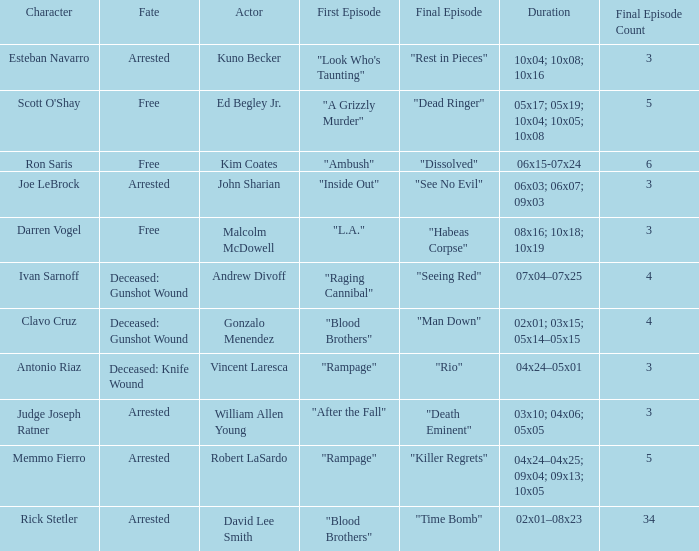What's the actor with character being judge joseph ratner William Allen Young. 